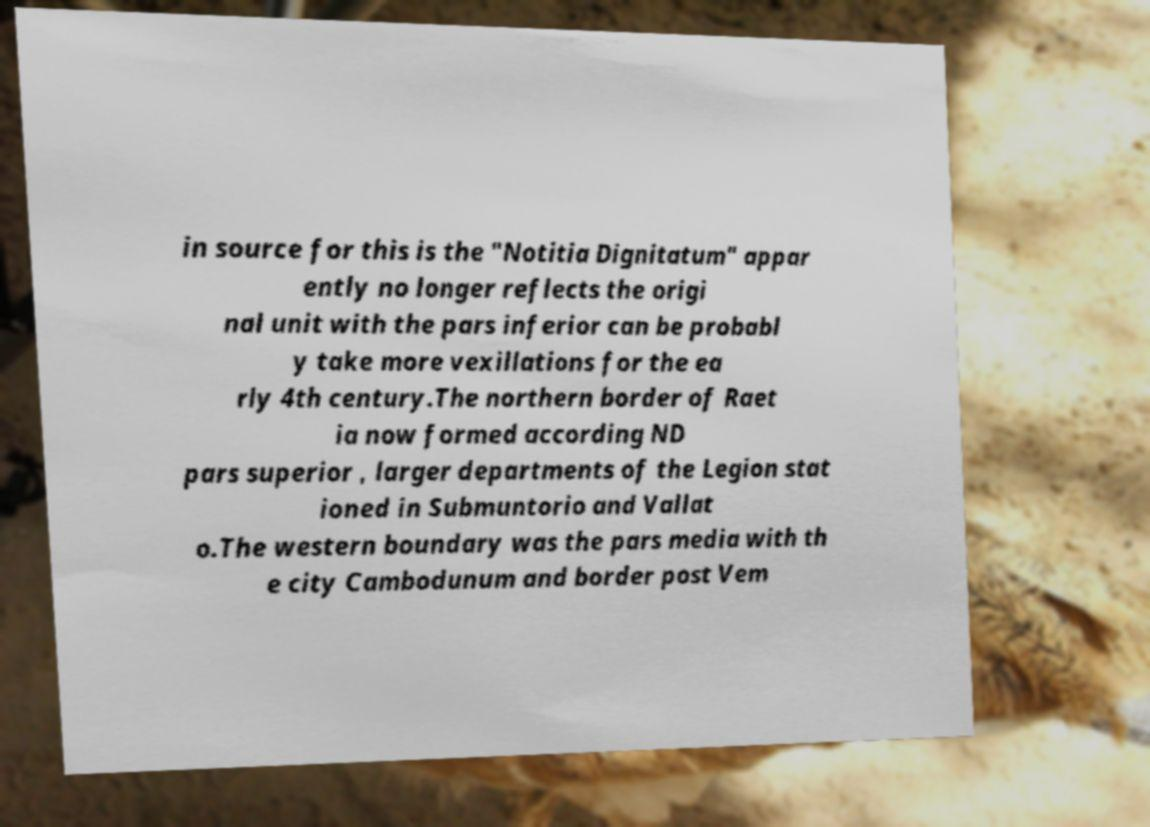I need the written content from this picture converted into text. Can you do that? in source for this is the "Notitia Dignitatum" appar ently no longer reflects the origi nal unit with the pars inferior can be probabl y take more vexillations for the ea rly 4th century.The northern border of Raet ia now formed according ND pars superior , larger departments of the Legion stat ioned in Submuntorio and Vallat o.The western boundary was the pars media with th e city Cambodunum and border post Vem 